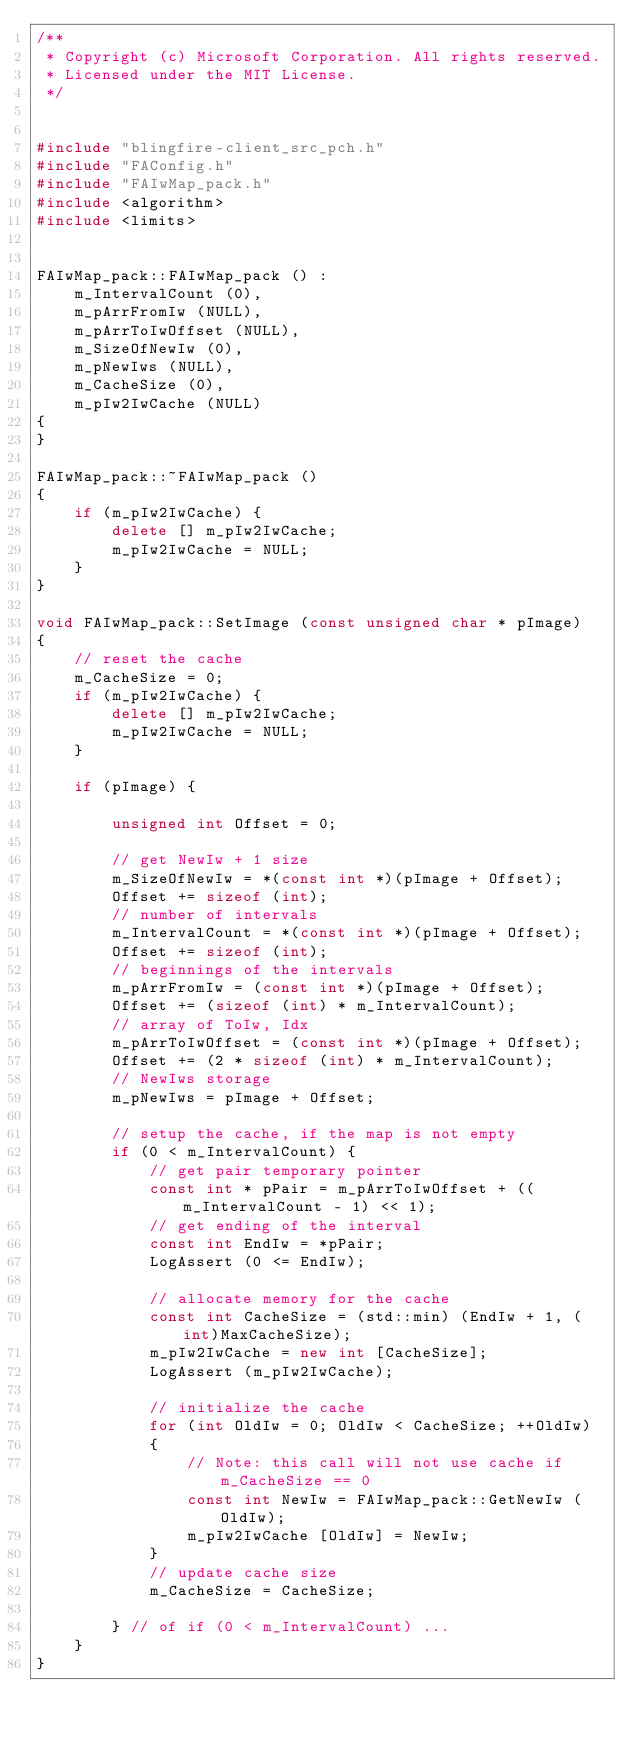<code> <loc_0><loc_0><loc_500><loc_500><_C++_>/**
 * Copyright (c) Microsoft Corporation. All rights reserved.
 * Licensed under the MIT License.
 */


#include "blingfire-client_src_pch.h"
#include "FAConfig.h"
#include "FAIwMap_pack.h"
#include <algorithm>
#include <limits>


FAIwMap_pack::FAIwMap_pack () :
    m_IntervalCount (0),
    m_pArrFromIw (NULL),
    m_pArrToIwOffset (NULL),
    m_SizeOfNewIw (0),
    m_pNewIws (NULL),
    m_CacheSize (0),
    m_pIw2IwCache (NULL)
{
}

FAIwMap_pack::~FAIwMap_pack ()
{
    if (m_pIw2IwCache) {
        delete [] m_pIw2IwCache;
        m_pIw2IwCache = NULL;
    }
}

void FAIwMap_pack::SetImage (const unsigned char * pImage)
{
    // reset the cache
    m_CacheSize = 0;
    if (m_pIw2IwCache) {
        delete [] m_pIw2IwCache;
        m_pIw2IwCache = NULL;
    }

    if (pImage) {

        unsigned int Offset = 0;

        // get NewIw + 1 size
        m_SizeOfNewIw = *(const int *)(pImage + Offset);
        Offset += sizeof (int);
        // number of intervals
        m_IntervalCount = *(const int *)(pImage + Offset);
        Offset += sizeof (int);
        // beginnings of the intervals
        m_pArrFromIw = (const int *)(pImage + Offset);
        Offset += (sizeof (int) * m_IntervalCount);
        // array of ToIw, Idx
        m_pArrToIwOffset = (const int *)(pImage + Offset);
        Offset += (2 * sizeof (int) * m_IntervalCount);
        // NewIws storage
        m_pNewIws = pImage + Offset;

        // setup the cache, if the map is not empty
        if (0 < m_IntervalCount) {
            // get pair temporary pointer
            const int * pPair = m_pArrToIwOffset + ((m_IntervalCount - 1) << 1);
            // get ending of the interval
            const int EndIw = *pPair;
            LogAssert (0 <= EndIw);

            // allocate memory for the cache
            const int CacheSize = (std::min) (EndIw + 1, (int)MaxCacheSize);
            m_pIw2IwCache = new int [CacheSize];
            LogAssert (m_pIw2IwCache);

            // initialize the cache
            for (int OldIw = 0; OldIw < CacheSize; ++OldIw)
            {
                // Note: this call will not use cache if m_CacheSize == 0
                const int NewIw = FAIwMap_pack::GetNewIw (OldIw);
                m_pIw2IwCache [OldIw] = NewIw;
            }
            // update cache size
            m_CacheSize = CacheSize;

        } // of if (0 < m_IntervalCount) ...
    }
}
</code> 